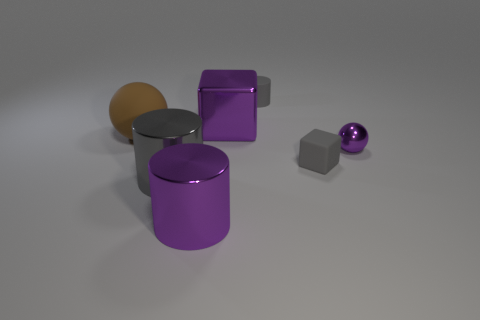Can you describe the arrangement and colors of the objects in the image? Certainly! In the image, there is a diverse assortment of geometric shapes. I see a large purple metal cube, a large purple cylinder, a smaller gray cube, and a small purple sphere. The layout is quite simple and uncluttered, with object positions that seem random on a light background. 